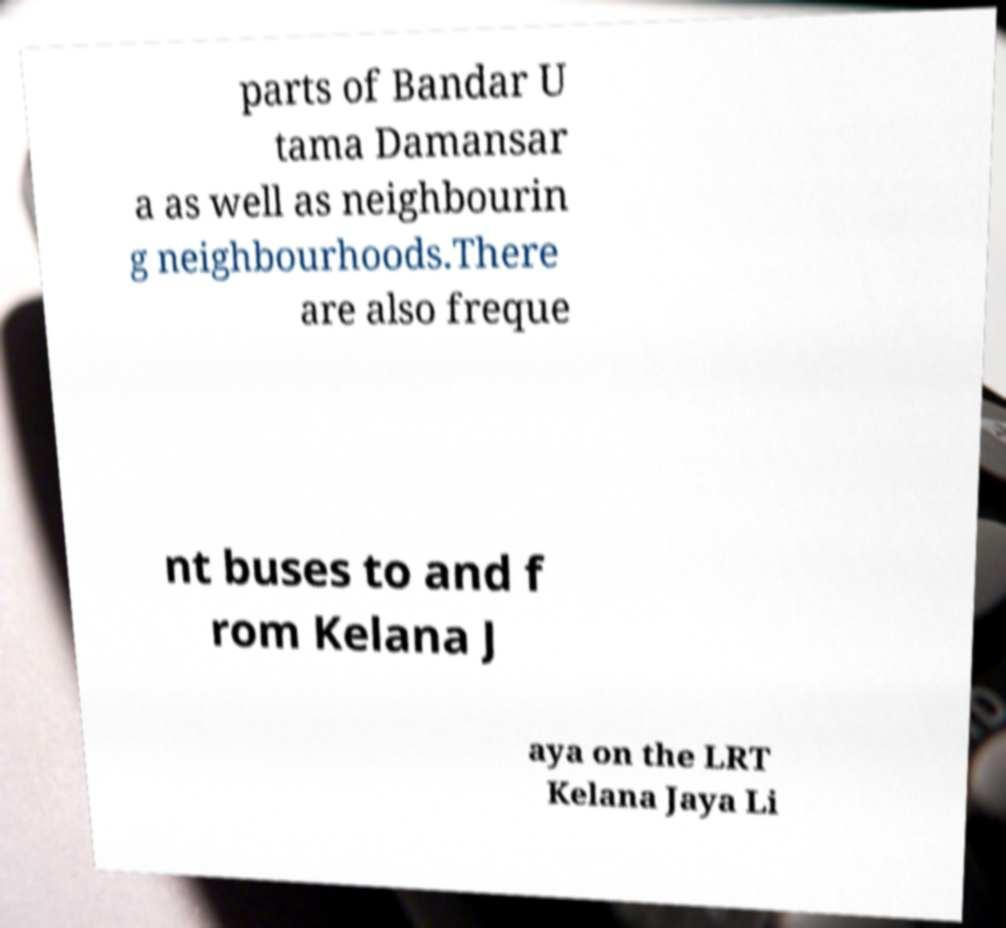Could you assist in decoding the text presented in this image and type it out clearly? parts of Bandar U tama Damansar a as well as neighbourin g neighbourhoods.There are also freque nt buses to and f rom Kelana J aya on the LRT Kelana Jaya Li 